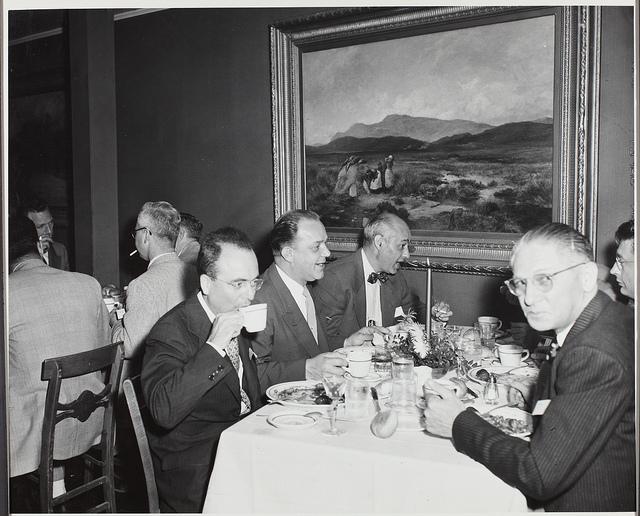Are these people married?
Quick response, please. No. Is this a modern day photograph?
Concise answer only. No. Where is the roll?
Keep it brief. Table. Who is the person in charge on this picture?
Keep it brief. Photographer. How many are sipping?
Write a very short answer. 1. 